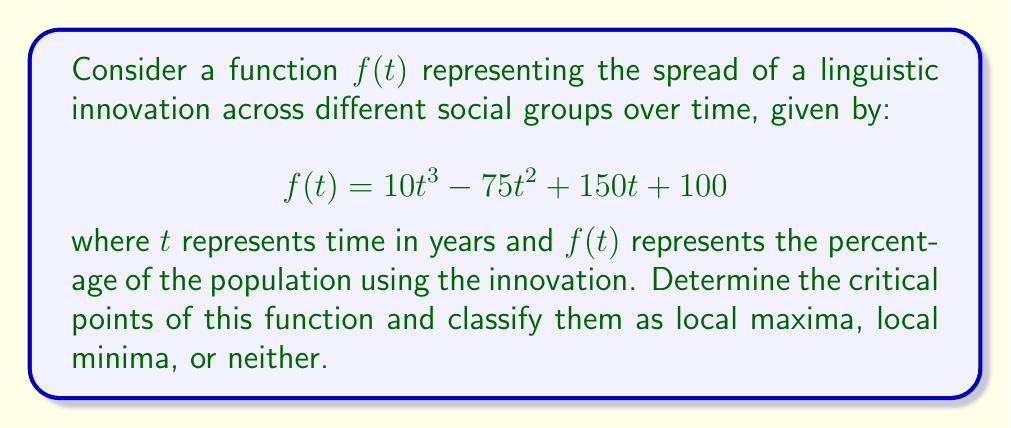Help me with this question. To find the critical points of the function $f(t) = 10t^3 - 75t^2 + 150t + 100$, we need to follow these steps:

1) First, we find the derivative of $f(t)$:
   $$f'(t) = 30t^2 - 150t + 150$$

2) Set $f'(t) = 0$ and solve for $t$:
   $$30t^2 - 150t + 150 = 0$$
   $$30(t^2 - 5t + 5) = 0$$
   $$t^2 - 5t + 5 = 0$$

3) Use the quadratic formula to solve this equation:
   $$t = \frac{5 \pm \sqrt{25 - 20}}{2} = \frac{5 \pm \sqrt{5}}{2}$$

4) This gives us two critical points:
   $$t_1 = \frac{5 + \sqrt{5}}{2} \approx 3.618$$
   $$t_2 = \frac{5 - \sqrt{5}}{2} \approx 1.382$$

5) To classify these points, we need to find the second derivative:
   $$f''(t) = 60t - 150$$

6) Evaluate $f''(t)$ at each critical point:
   $$f''(t_1) = 60(\frac{5 + \sqrt{5}}{2}) - 150 = 150 + 30\sqrt{5} - 150 = 30\sqrt{5} > 0$$
   $$f''(t_2) = 60(\frac{5 - \sqrt{5}}{2}) - 150 = 150 - 30\sqrt{5} - 150 = -30\sqrt{5} < 0$$

7) Since $f''(t_1) > 0$, $t_1$ is a local minimum.
   Since $f''(t_2) < 0$, $t_2$ is a local maximum.
Answer: The critical points are $t_1 = \frac{5 + \sqrt{5}}{2} \approx 3.618$ (local minimum) and $t_2 = \frac{5 - \sqrt{5}}{2} \approx 1.382$ (local maximum). 